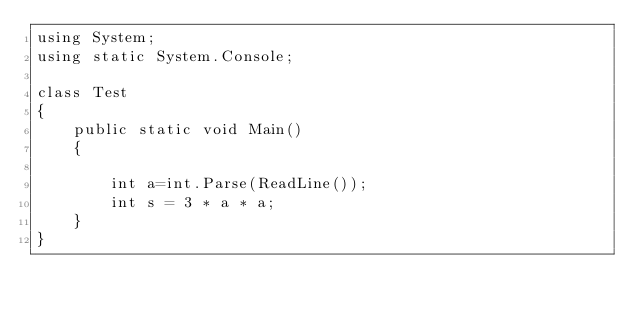<code> <loc_0><loc_0><loc_500><loc_500><_C#_>using System;
using static System.Console;

class Test
{
    public static void Main()
    {
        
        int a=int.Parse(ReadLine());
        int s = 3 * a * a;
    }
}</code> 